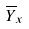Convert formula to latex. <formula><loc_0><loc_0><loc_500><loc_500>\overline { Y } _ { x }</formula> 